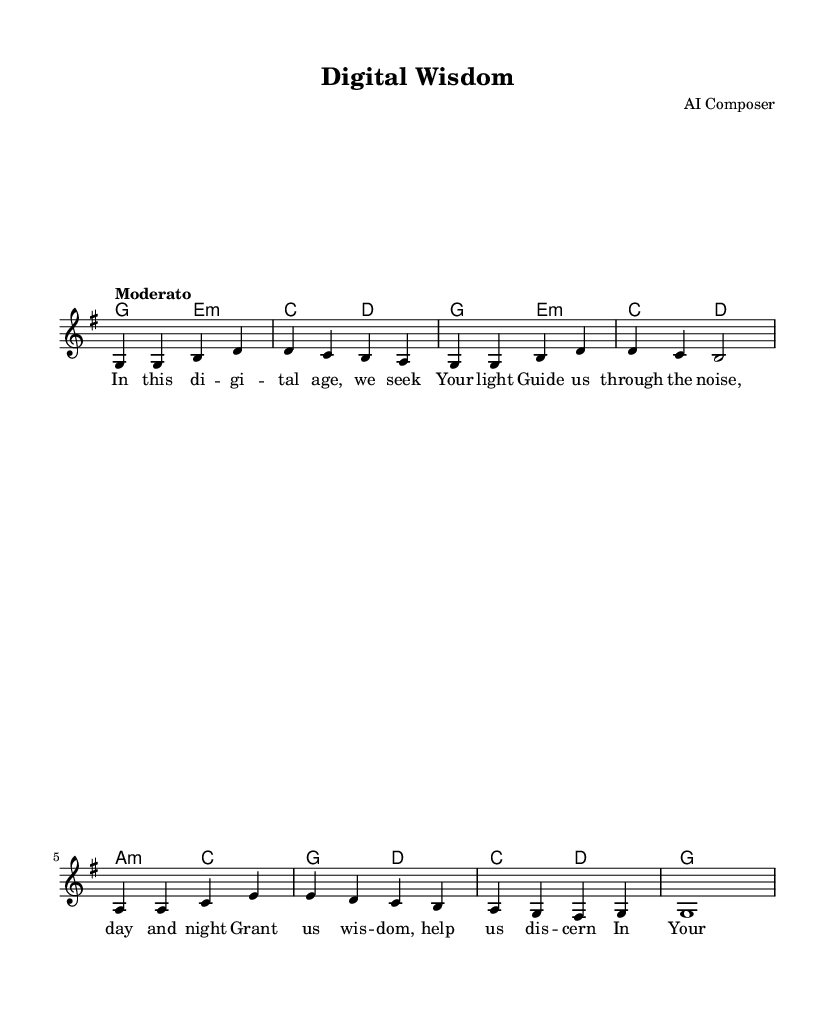What is the key signature of this music? The key signature is G major, which has one sharp (F#). This can be identified by looking at the key signature at the beginning of the staff where there's a sharp sign on the F line of the treble clef.
Answer: G major What is the time signature of this piece? The time signature is 4/4, indicated at the beginning of the score. It tells us that there are four beats in each measure and that the quarter note gets one beat.
Answer: 4/4 What is the tempo marking for this piece? The tempo marking is "Moderato," which suggests a moderate pace. This indication is typically located above the staff at the beginning of the score.
Answer: Moderato What is the main theme of the lyrics? The main theme focuses on seeking divine guidance and wisdom in the digital age. The lyrics express a desire for discernment amidst confusion, which aligns with the song's title.
Answer: Seeking divine guidance How many measures are in the melody section? The melody section consists of eight measures, which can be counted by reviewing the provided melody line and noting the separate groupings indicated by vertical lines.
Answer: Eight measures What is the last note of the melody? The last note of the melody is a whole note (g) and is located at the end of the melody line. It is visually represented as a note that sustains across the last measure.
Answer: g What emotional tone does the song convey? The song conveys a tone of reflection and yearning for wisdom and clarity, emphasizing a connection to spiritual guidance amidst the complexities of modern life. This assessment can be drawn from the lyrical content and musical phrasing.
Answer: Reflective 